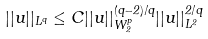<formula> <loc_0><loc_0><loc_500><loc_500>| | u | | _ { L ^ { q } } \leq C | | u | | _ { W _ { 2 } ^ { p } } ^ { ( q - 2 ) / q } | | u | | _ { L ^ { 2 } } ^ { 2 / q }</formula> 